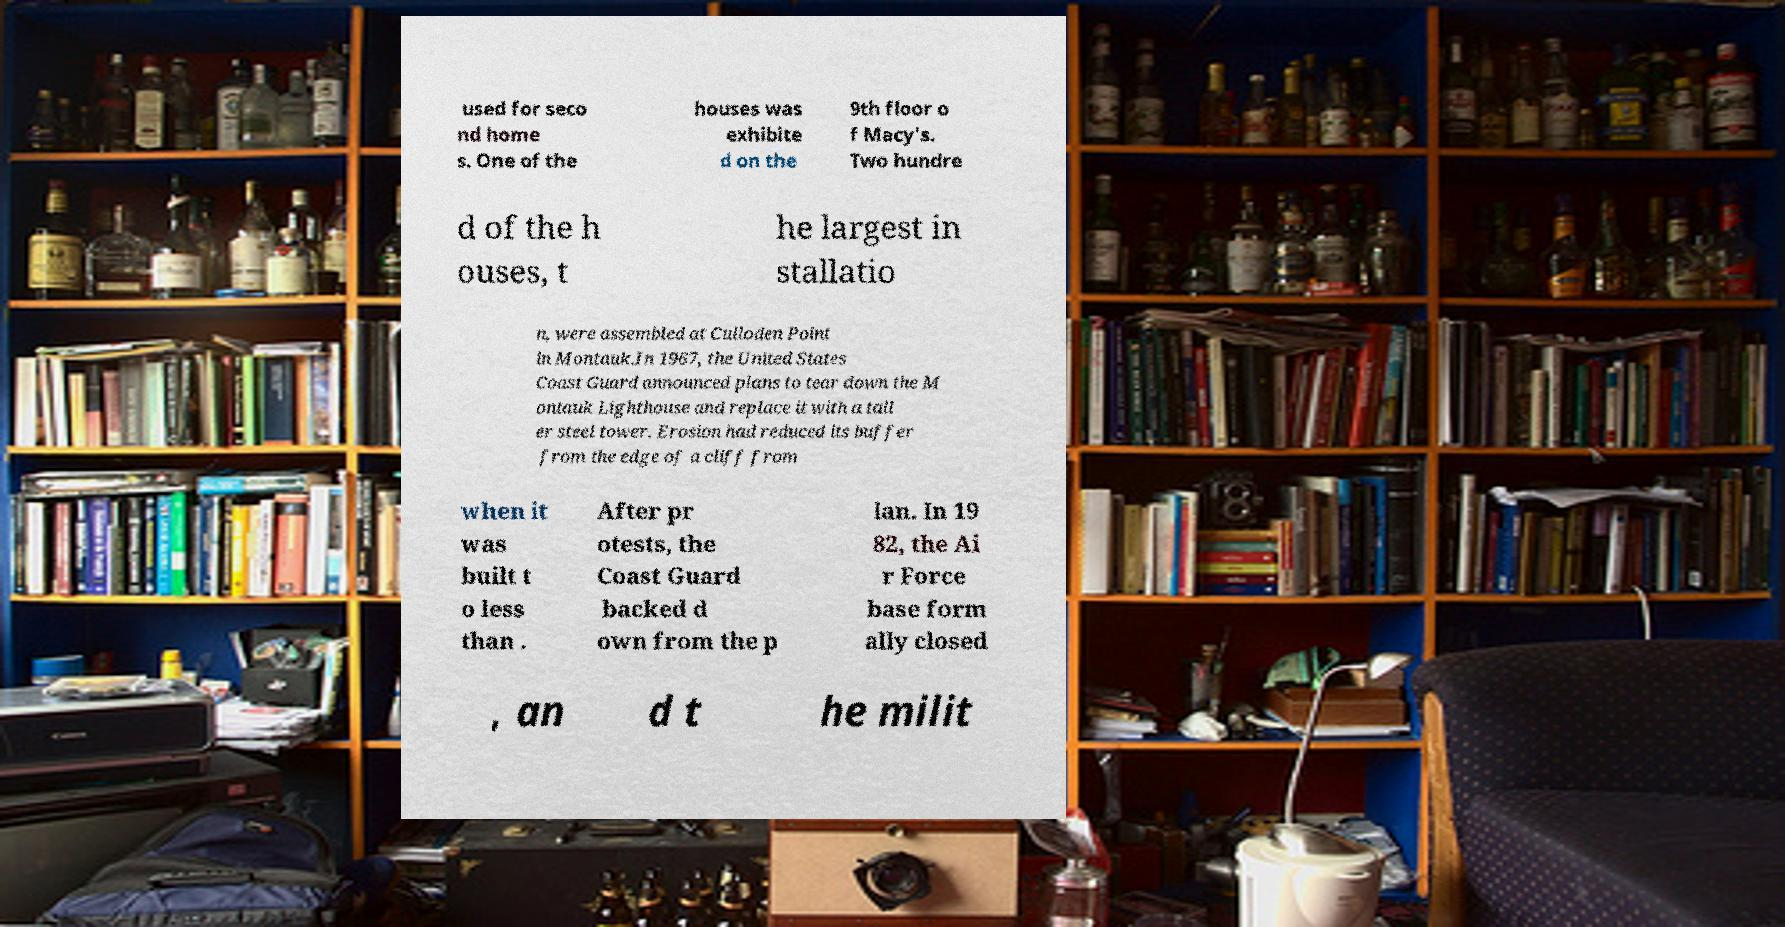There's text embedded in this image that I need extracted. Can you transcribe it verbatim? used for seco nd home s. One of the houses was exhibite d on the 9th floor o f Macy's. Two hundre d of the h ouses, t he largest in stallatio n, were assembled at Culloden Point in Montauk.In 1967, the United States Coast Guard announced plans to tear down the M ontauk Lighthouse and replace it with a tall er steel tower. Erosion had reduced its buffer from the edge of a cliff from when it was built t o less than . After pr otests, the Coast Guard backed d own from the p lan. In 19 82, the Ai r Force base form ally closed , an d t he milit 